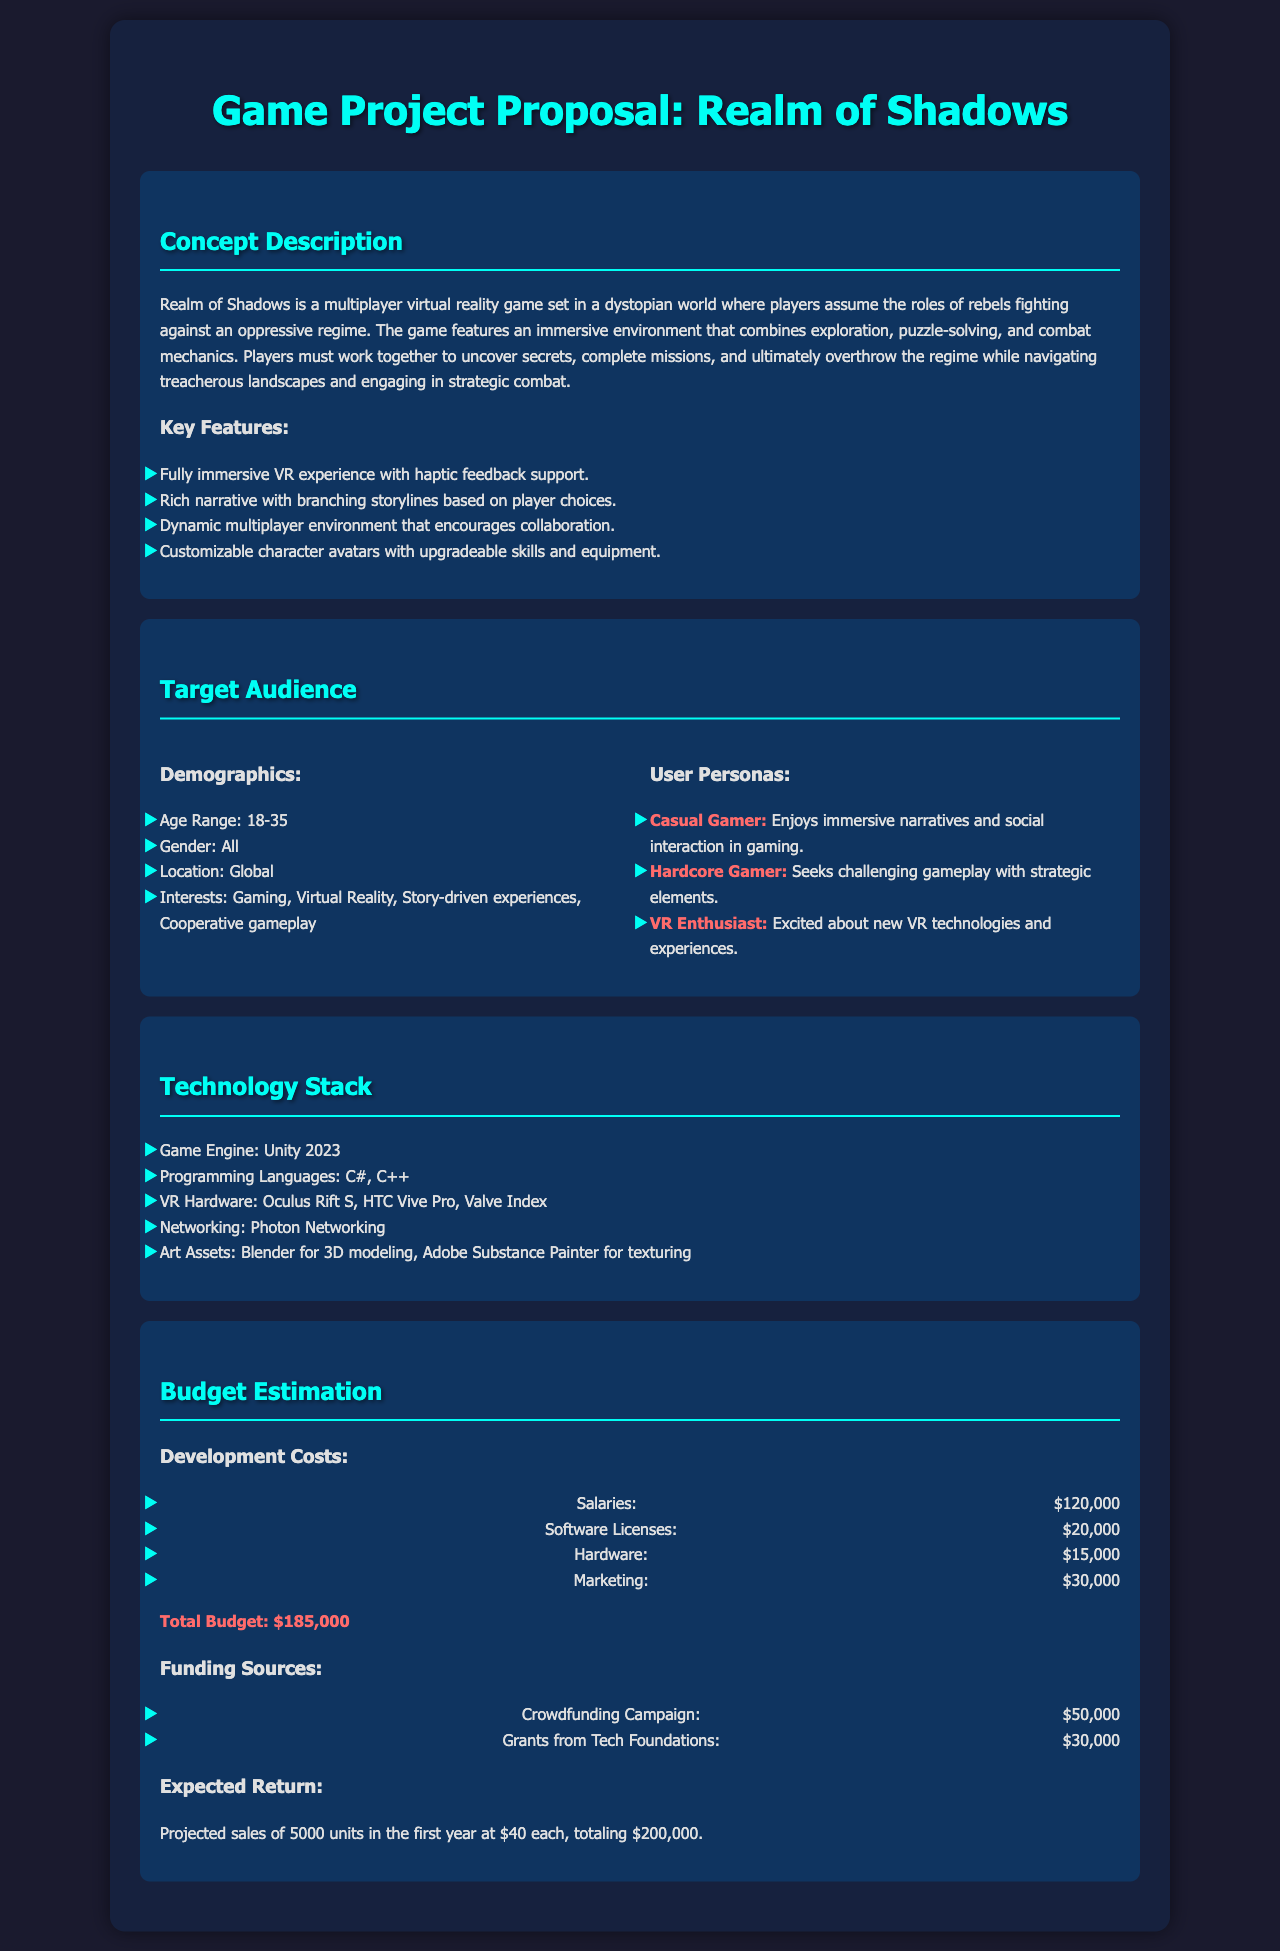What is the title of the game project? The title of the game project is specified at the top of the document.
Answer: Realm of Shadows What is the age range of the target audience? The document lists the age range in the demographics section.
Answer: 18-35 What technologies are included in the technology stack? The technology stack section lists various technologies used in the project.
Answer: Unity 2023, C#, C++, Oculus Rift S, HTC Vive Pro, Valve Index, Photon Networking, Blender, Adobe Substance Painter What is the estimated total budget for the game? The total budget is summarized under the budget estimation section.
Answer: $185,000 What target persona is described as enjoying immersive narratives? The document describes different user personas in the target audience section.
Answer: Casual Gamer What is the budget allocated for marketing? The marketing budget is listed under development costs in the budget estimation section.
Answer: $30,000 What will be the expected sales revenue in the first year? The document provides a projection of sales and revenue in the budget estimation section.
Answer: $200,000 What type of game is "Realm of Shadows"? The concept description clearly defines the genre and style of the game.
Answer: Multiplayer virtual reality game What are the three main aspects of gameplay mentioned? The gameplay features are listed in the concept description.
Answer: Exploration, puzzle-solving, and combat mechanics 